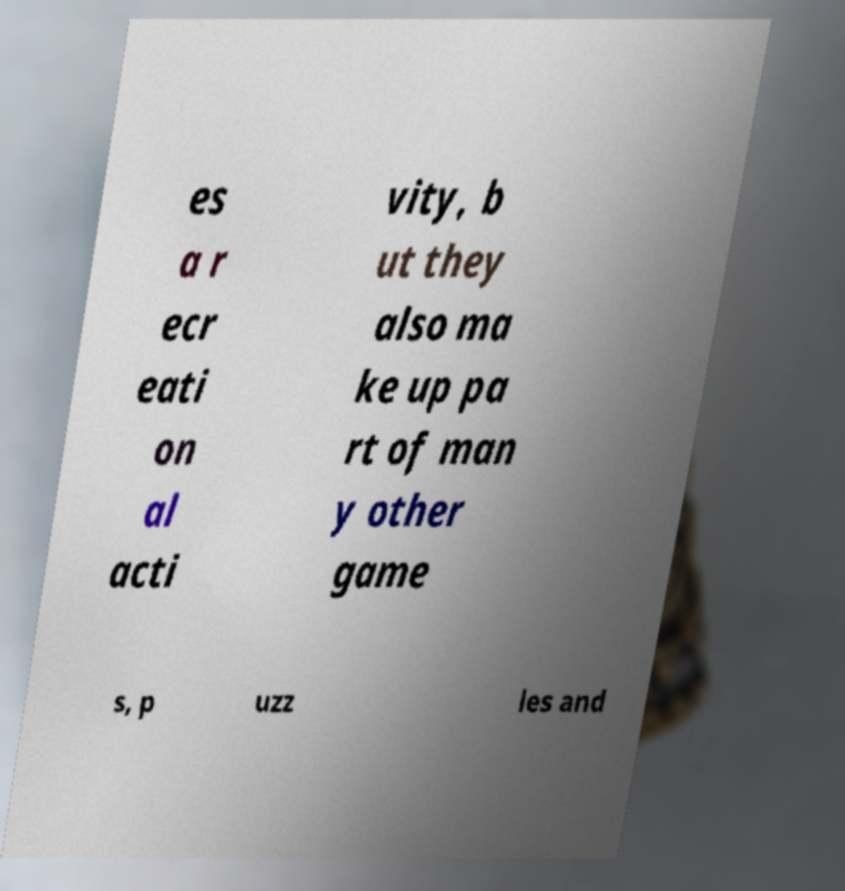Please identify and transcribe the text found in this image. es a r ecr eati on al acti vity, b ut they also ma ke up pa rt of man y other game s, p uzz les and 